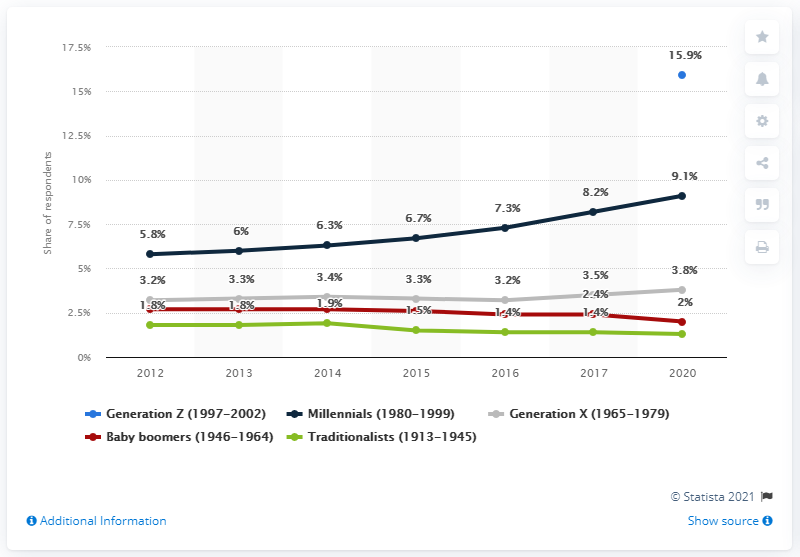Outline some significant characteristics in this image. Approximately 15.9% of Millennials identify as LGBT. 